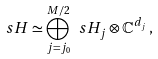<formula> <loc_0><loc_0><loc_500><loc_500>\ s H \simeq \bigoplus _ { j = j _ { 0 } } ^ { M / 2 } \ s H _ { j } \otimes \mathbb { C } ^ { d _ { j } } \, ,</formula> 